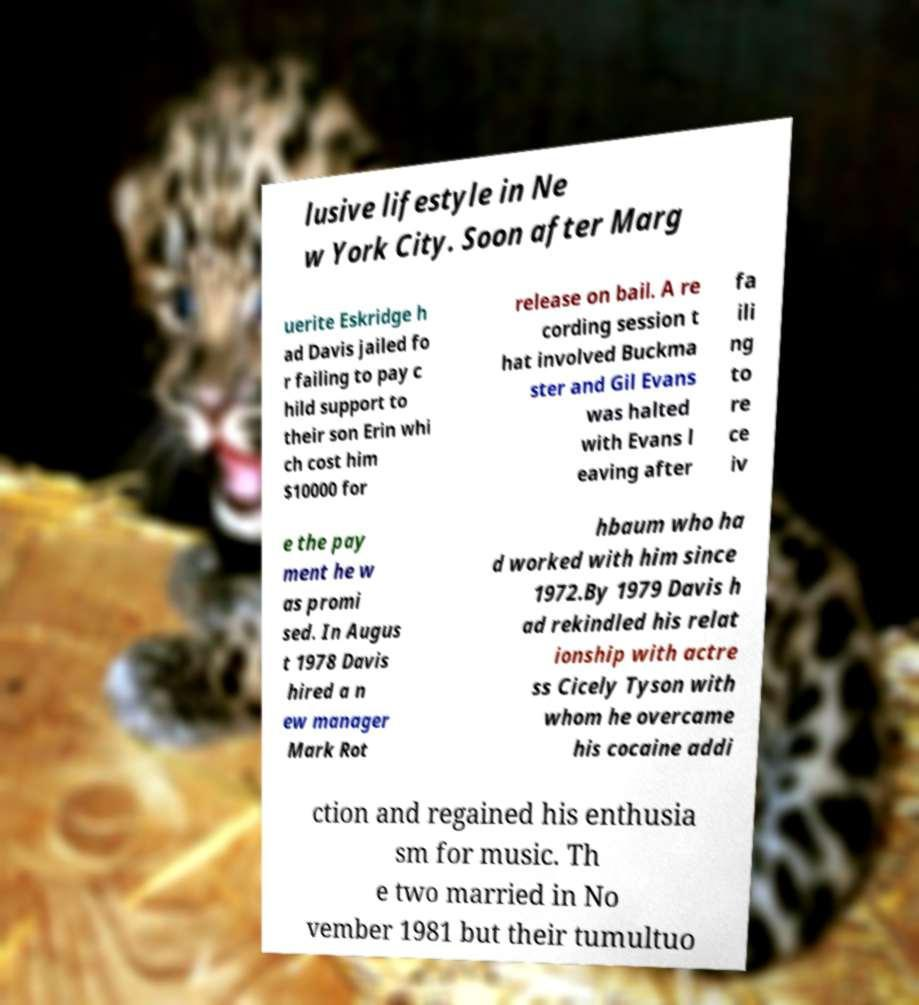I need the written content from this picture converted into text. Can you do that? lusive lifestyle in Ne w York City. Soon after Marg uerite Eskridge h ad Davis jailed fo r failing to pay c hild support to their son Erin whi ch cost him $10000 for release on bail. A re cording session t hat involved Buckma ster and Gil Evans was halted with Evans l eaving after fa ili ng to re ce iv e the pay ment he w as promi sed. In Augus t 1978 Davis hired a n ew manager Mark Rot hbaum who ha d worked with him since 1972.By 1979 Davis h ad rekindled his relat ionship with actre ss Cicely Tyson with whom he overcame his cocaine addi ction and regained his enthusia sm for music. Th e two married in No vember 1981 but their tumultuo 